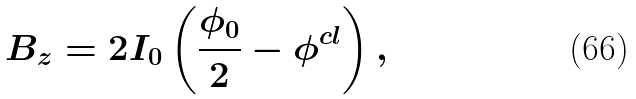Convert formula to latex. <formula><loc_0><loc_0><loc_500><loc_500>B _ { z } = 2 I _ { 0 } \left ( \frac { \phi _ { 0 } } { 2 } - \phi ^ { c l } \right ) ,</formula> 